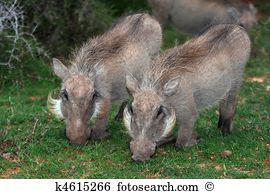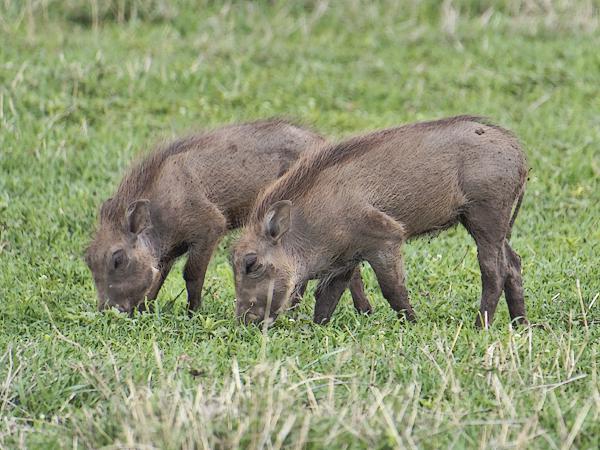The first image is the image on the left, the second image is the image on the right. Considering the images on both sides, is "A hog and two baby hogs are grazing in the left picture." valid? Answer yes or no. No. 